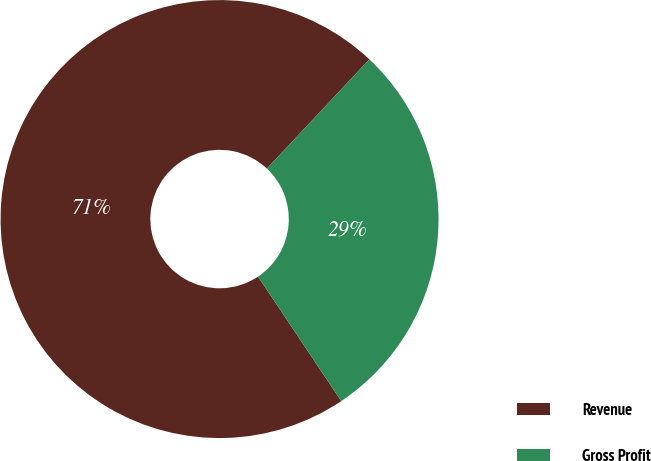Convert chart to OTSL. <chart><loc_0><loc_0><loc_500><loc_500><pie_chart><fcel>Revenue<fcel>Gross Profit<nl><fcel>71.37%<fcel>28.63%<nl></chart> 